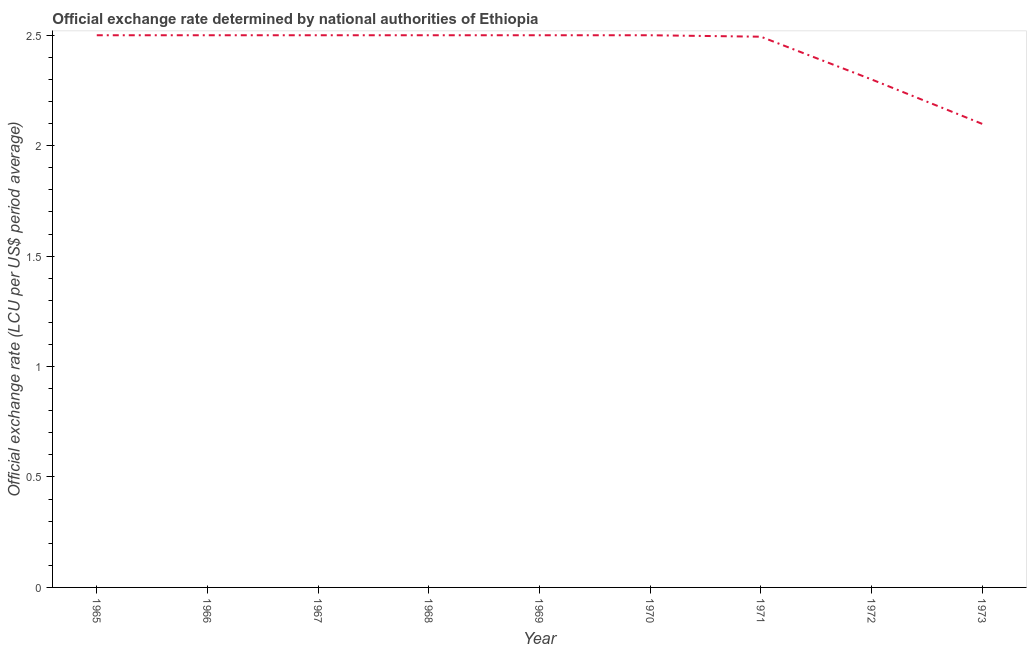What is the official exchange rate in 1966?
Your answer should be compact. 2.5. Across all years, what is the maximum official exchange rate?
Ensure brevity in your answer.  2.5. Across all years, what is the minimum official exchange rate?
Provide a short and direct response. 2.1. In which year was the official exchange rate maximum?
Offer a very short reply. 1965. What is the sum of the official exchange rate?
Offer a terse response. 21.89. What is the difference between the official exchange rate in 1965 and 1972?
Give a very brief answer. 0.2. What is the average official exchange rate per year?
Offer a very short reply. 2.43. What is the median official exchange rate?
Keep it short and to the point. 2.5. In how many years, is the official exchange rate greater than 1 ?
Give a very brief answer. 9. Do a majority of the years between 1967 and 1969 (inclusive) have official exchange rate greater than 1.1 ?
Offer a very short reply. Yes. What is the ratio of the official exchange rate in 1968 to that in 1971?
Provide a succinct answer. 1. Is the sum of the official exchange rate in 1966 and 1968 greater than the maximum official exchange rate across all years?
Your answer should be very brief. Yes. What is the difference between the highest and the lowest official exchange rate?
Ensure brevity in your answer.  0.4. How many lines are there?
Provide a succinct answer. 1. Does the graph contain any zero values?
Provide a short and direct response. No. What is the title of the graph?
Provide a succinct answer. Official exchange rate determined by national authorities of Ethiopia. What is the label or title of the X-axis?
Offer a terse response. Year. What is the label or title of the Y-axis?
Your response must be concise. Official exchange rate (LCU per US$ period average). What is the Official exchange rate (LCU per US$ period average) in 1965?
Your answer should be very brief. 2.5. What is the Official exchange rate (LCU per US$ period average) of 1966?
Make the answer very short. 2.5. What is the Official exchange rate (LCU per US$ period average) of 1967?
Make the answer very short. 2.5. What is the Official exchange rate (LCU per US$ period average) in 1968?
Give a very brief answer. 2.5. What is the Official exchange rate (LCU per US$ period average) in 1969?
Make the answer very short. 2.5. What is the Official exchange rate (LCU per US$ period average) in 1970?
Provide a succinct answer. 2.5. What is the Official exchange rate (LCU per US$ period average) of 1971?
Provide a short and direct response. 2.49. What is the Official exchange rate (LCU per US$ period average) in 1972?
Your answer should be very brief. 2.3. What is the Official exchange rate (LCU per US$ period average) of 1973?
Provide a succinct answer. 2.1. What is the difference between the Official exchange rate (LCU per US$ period average) in 1965 and 1968?
Offer a terse response. 0. What is the difference between the Official exchange rate (LCU per US$ period average) in 1965 and 1969?
Offer a very short reply. 0. What is the difference between the Official exchange rate (LCU per US$ period average) in 1965 and 1970?
Make the answer very short. 0. What is the difference between the Official exchange rate (LCU per US$ period average) in 1965 and 1971?
Your response must be concise. 0.01. What is the difference between the Official exchange rate (LCU per US$ period average) in 1965 and 1972?
Make the answer very short. 0.2. What is the difference between the Official exchange rate (LCU per US$ period average) in 1965 and 1973?
Your answer should be compact. 0.4. What is the difference between the Official exchange rate (LCU per US$ period average) in 1966 and 1968?
Provide a succinct answer. 0. What is the difference between the Official exchange rate (LCU per US$ period average) in 1966 and 1969?
Your response must be concise. 0. What is the difference between the Official exchange rate (LCU per US$ period average) in 1966 and 1970?
Provide a succinct answer. 0. What is the difference between the Official exchange rate (LCU per US$ period average) in 1966 and 1971?
Your response must be concise. 0.01. What is the difference between the Official exchange rate (LCU per US$ period average) in 1966 and 1973?
Your response must be concise. 0.4. What is the difference between the Official exchange rate (LCU per US$ period average) in 1967 and 1971?
Make the answer very short. 0.01. What is the difference between the Official exchange rate (LCU per US$ period average) in 1967 and 1972?
Make the answer very short. 0.2. What is the difference between the Official exchange rate (LCU per US$ period average) in 1967 and 1973?
Give a very brief answer. 0.4. What is the difference between the Official exchange rate (LCU per US$ period average) in 1968 and 1971?
Your answer should be very brief. 0.01. What is the difference between the Official exchange rate (LCU per US$ period average) in 1968 and 1972?
Your answer should be compact. 0.2. What is the difference between the Official exchange rate (LCU per US$ period average) in 1968 and 1973?
Give a very brief answer. 0.4. What is the difference between the Official exchange rate (LCU per US$ period average) in 1969 and 1971?
Provide a short and direct response. 0.01. What is the difference between the Official exchange rate (LCU per US$ period average) in 1969 and 1973?
Your answer should be very brief. 0.4. What is the difference between the Official exchange rate (LCU per US$ period average) in 1970 and 1971?
Your answer should be compact. 0.01. What is the difference between the Official exchange rate (LCU per US$ period average) in 1970 and 1973?
Your answer should be very brief. 0.4. What is the difference between the Official exchange rate (LCU per US$ period average) in 1971 and 1972?
Your answer should be very brief. 0.19. What is the difference between the Official exchange rate (LCU per US$ period average) in 1971 and 1973?
Your response must be concise. 0.39. What is the difference between the Official exchange rate (LCU per US$ period average) in 1972 and 1973?
Keep it short and to the point. 0.2. What is the ratio of the Official exchange rate (LCU per US$ period average) in 1965 to that in 1966?
Keep it short and to the point. 1. What is the ratio of the Official exchange rate (LCU per US$ period average) in 1965 to that in 1967?
Offer a very short reply. 1. What is the ratio of the Official exchange rate (LCU per US$ period average) in 1965 to that in 1968?
Your response must be concise. 1. What is the ratio of the Official exchange rate (LCU per US$ period average) in 1965 to that in 1969?
Ensure brevity in your answer.  1. What is the ratio of the Official exchange rate (LCU per US$ period average) in 1965 to that in 1970?
Ensure brevity in your answer.  1. What is the ratio of the Official exchange rate (LCU per US$ period average) in 1965 to that in 1971?
Provide a succinct answer. 1. What is the ratio of the Official exchange rate (LCU per US$ period average) in 1965 to that in 1972?
Provide a short and direct response. 1.09. What is the ratio of the Official exchange rate (LCU per US$ period average) in 1965 to that in 1973?
Your answer should be very brief. 1.19. What is the ratio of the Official exchange rate (LCU per US$ period average) in 1966 to that in 1967?
Make the answer very short. 1. What is the ratio of the Official exchange rate (LCU per US$ period average) in 1966 to that in 1968?
Offer a terse response. 1. What is the ratio of the Official exchange rate (LCU per US$ period average) in 1966 to that in 1970?
Your response must be concise. 1. What is the ratio of the Official exchange rate (LCU per US$ period average) in 1966 to that in 1972?
Make the answer very short. 1.09. What is the ratio of the Official exchange rate (LCU per US$ period average) in 1966 to that in 1973?
Your response must be concise. 1.19. What is the ratio of the Official exchange rate (LCU per US$ period average) in 1967 to that in 1971?
Provide a short and direct response. 1. What is the ratio of the Official exchange rate (LCU per US$ period average) in 1967 to that in 1972?
Offer a terse response. 1.09. What is the ratio of the Official exchange rate (LCU per US$ period average) in 1967 to that in 1973?
Make the answer very short. 1.19. What is the ratio of the Official exchange rate (LCU per US$ period average) in 1968 to that in 1971?
Offer a terse response. 1. What is the ratio of the Official exchange rate (LCU per US$ period average) in 1968 to that in 1972?
Offer a terse response. 1.09. What is the ratio of the Official exchange rate (LCU per US$ period average) in 1968 to that in 1973?
Your answer should be very brief. 1.19. What is the ratio of the Official exchange rate (LCU per US$ period average) in 1969 to that in 1970?
Make the answer very short. 1. What is the ratio of the Official exchange rate (LCU per US$ period average) in 1969 to that in 1972?
Ensure brevity in your answer.  1.09. What is the ratio of the Official exchange rate (LCU per US$ period average) in 1969 to that in 1973?
Ensure brevity in your answer.  1.19. What is the ratio of the Official exchange rate (LCU per US$ period average) in 1970 to that in 1972?
Provide a succinct answer. 1.09. What is the ratio of the Official exchange rate (LCU per US$ period average) in 1970 to that in 1973?
Your answer should be compact. 1.19. What is the ratio of the Official exchange rate (LCU per US$ period average) in 1971 to that in 1972?
Make the answer very short. 1.08. What is the ratio of the Official exchange rate (LCU per US$ period average) in 1971 to that in 1973?
Your response must be concise. 1.19. What is the ratio of the Official exchange rate (LCU per US$ period average) in 1972 to that in 1973?
Provide a short and direct response. 1.1. 